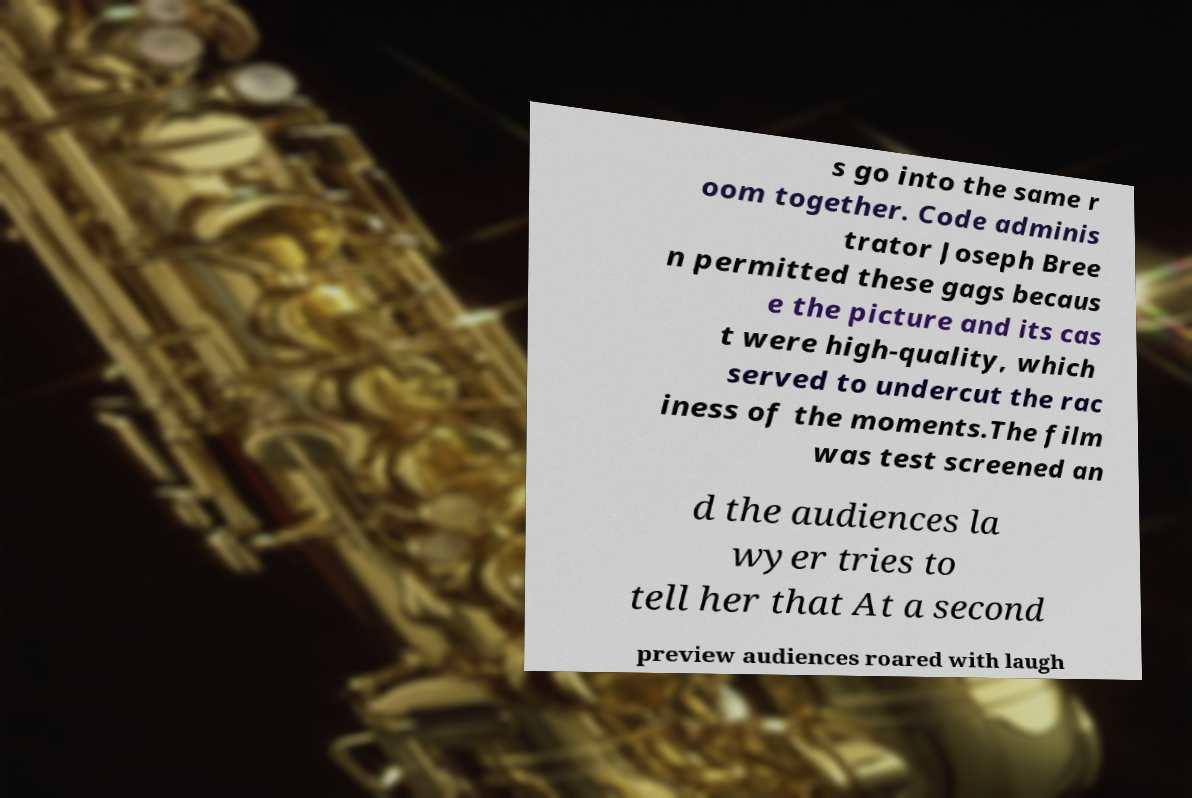I need the written content from this picture converted into text. Can you do that? s go into the same r oom together. Code adminis trator Joseph Bree n permitted these gags becaus e the picture and its cas t were high-quality, which served to undercut the rac iness of the moments.The film was test screened an d the audiences la wyer tries to tell her that At a second preview audiences roared with laugh 